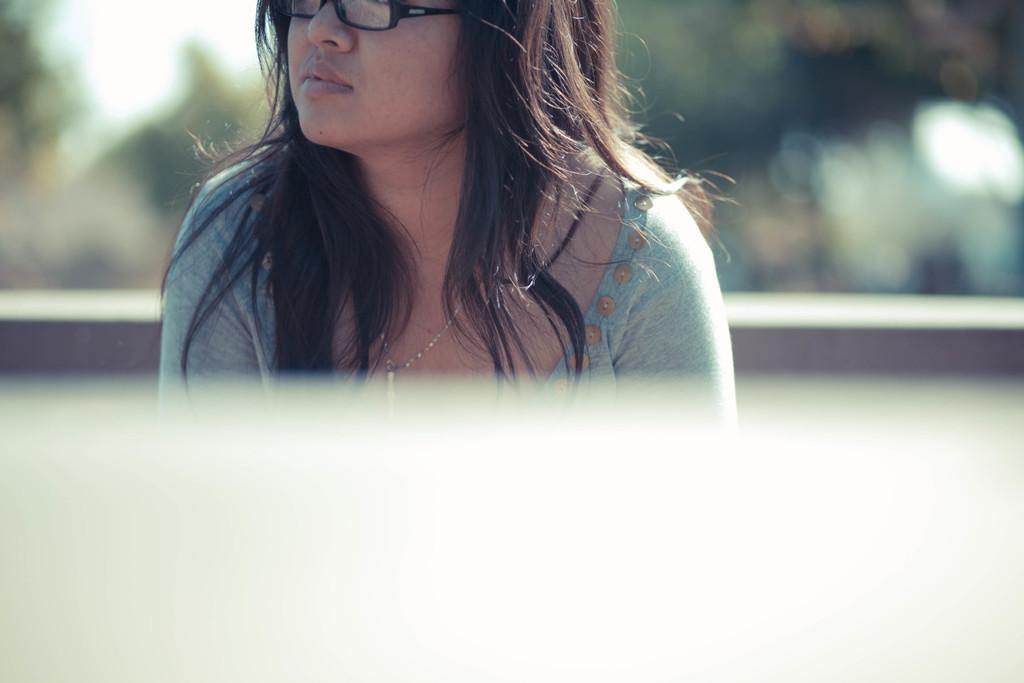How would you summarize this image in a sentence or two? In this image in the front there is a woman wearing spects and the background is blurry. 